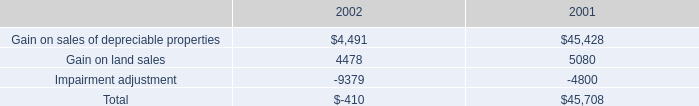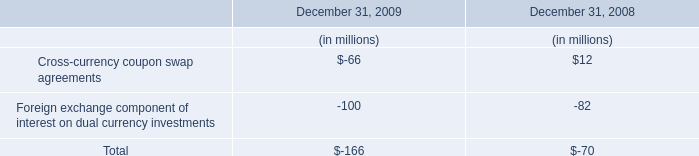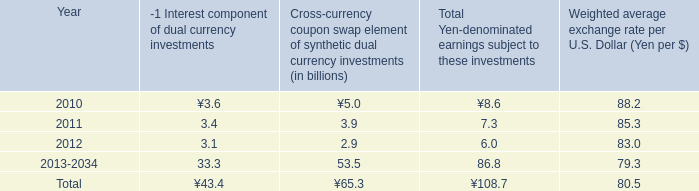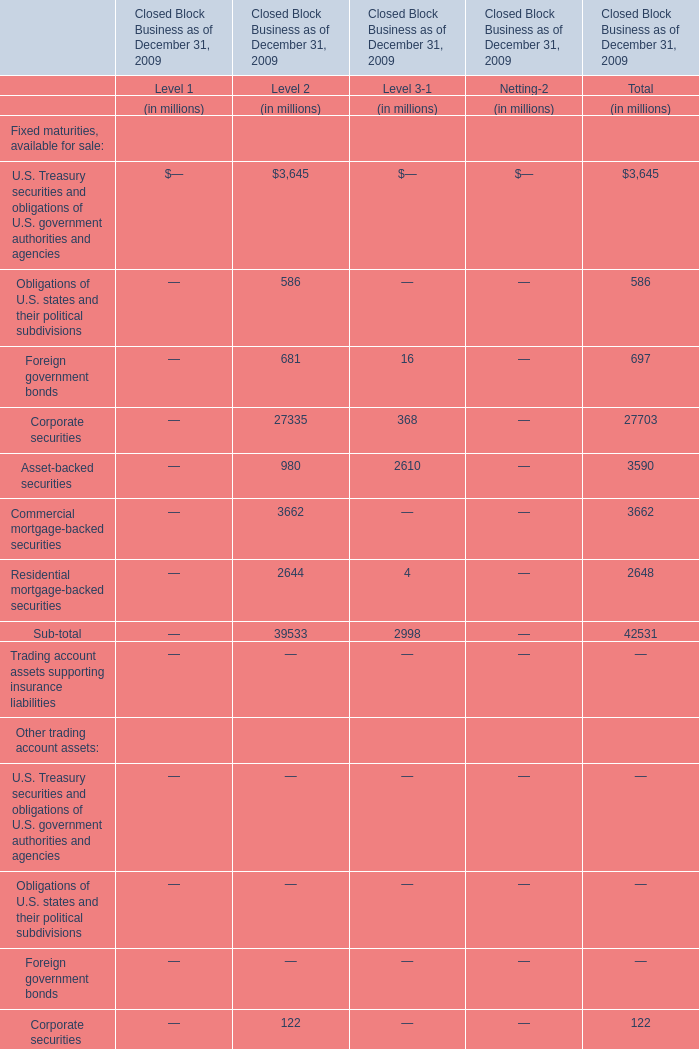What's the 10 % of total elements for Level 3-1 in 2009? (in million) 
Computations: (3048 * 0.1)
Answer: 304.8. 